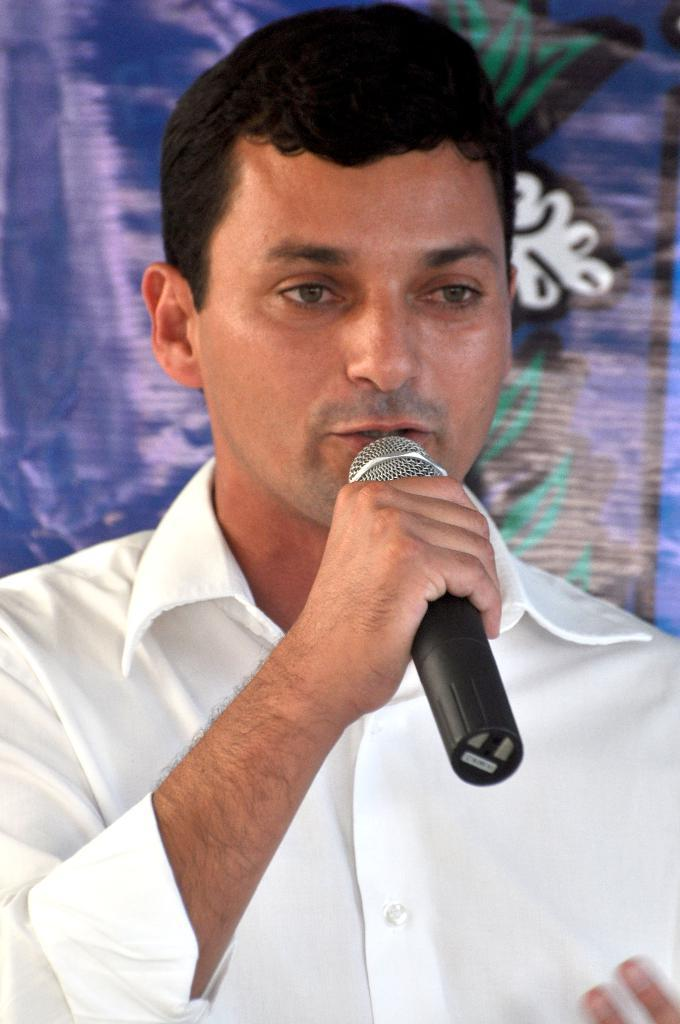What is the main subject of the image? The main subject of the image is a man. What is the man holding in his hand? The man is holding a microphone in his hand. What is the man doing with the microphone? The man is talking. How many clovers can be seen growing around the man in the image? There are no clovers visible in the image; it features a man holding a microphone and talking. How many pizzas is the man eating in the image? There is no indication in the image that the man is eating any pizzas. 